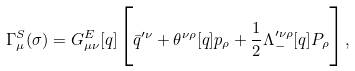Convert formula to latex. <formula><loc_0><loc_0><loc_500><loc_500>\Gamma _ { \mu } ^ { S } ( \sigma ) = G ^ { E } _ { \mu \nu } [ q ] \Big { [ } { \bar { q } } ^ { \prime \nu } + \theta ^ { \nu \rho } [ q ] p _ { \rho } + \frac { 1 } { 2 } { \Lambda } _ { - } ^ { \prime \nu \rho } [ q ] P _ { \rho } \Big { ] } ,</formula> 